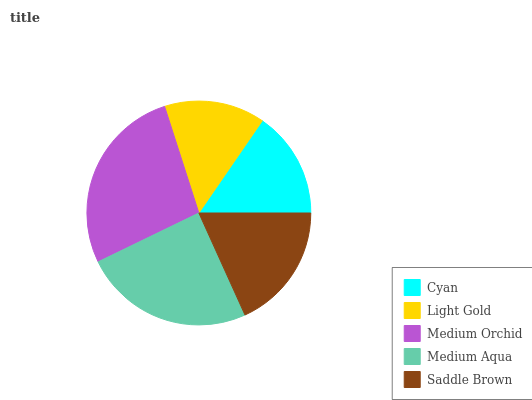Is Light Gold the minimum?
Answer yes or no. Yes. Is Medium Orchid the maximum?
Answer yes or no. Yes. Is Medium Orchid the minimum?
Answer yes or no. No. Is Light Gold the maximum?
Answer yes or no. No. Is Medium Orchid greater than Light Gold?
Answer yes or no. Yes. Is Light Gold less than Medium Orchid?
Answer yes or no. Yes. Is Light Gold greater than Medium Orchid?
Answer yes or no. No. Is Medium Orchid less than Light Gold?
Answer yes or no. No. Is Saddle Brown the high median?
Answer yes or no. Yes. Is Saddle Brown the low median?
Answer yes or no. Yes. Is Light Gold the high median?
Answer yes or no. No. Is Medium Orchid the low median?
Answer yes or no. No. 